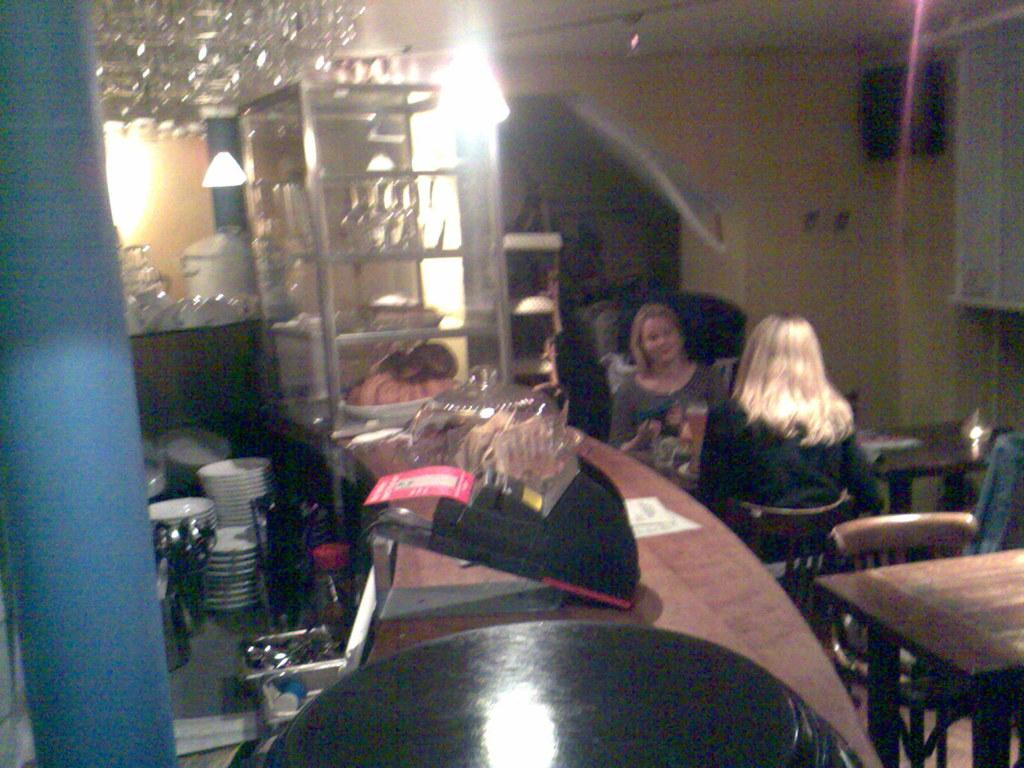What is on the table in the image? There is a paper on the table, along with other objects. Who is present in the image? There are women seated on chairs in the image. What can be seen in the background? There are plates and lights in the background. What type of hen is being carried by the police officer in the image? There is no hen or police officer present in the image. Can you tell me how many porters are assisting the women in the image? There is no mention of porters or any assistance being provided to the women in the image. 